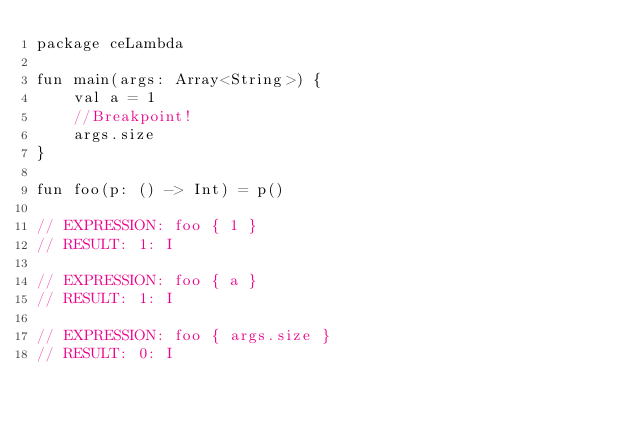<code> <loc_0><loc_0><loc_500><loc_500><_Kotlin_>package ceLambda

fun main(args: Array<String>) {
    val a = 1
    //Breakpoint!
    args.size
}

fun foo(p: () -> Int) = p()

// EXPRESSION: foo { 1 }
// RESULT: 1: I

// EXPRESSION: foo { a }
// RESULT: 1: I

// EXPRESSION: foo { args.size }
// RESULT: 0: I

</code> 